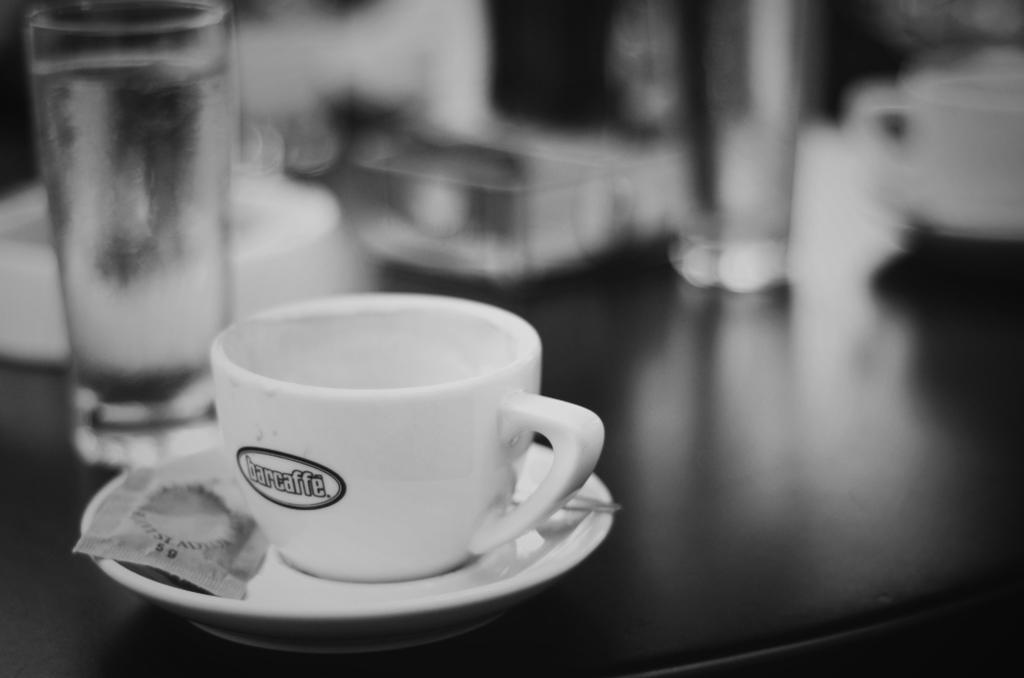In one or two sentences, can you explain what this image depicts? In this picture there is a cup and saucer and a sachet placed on it. There are two glasses on the table And a cup on the right side of the image. 